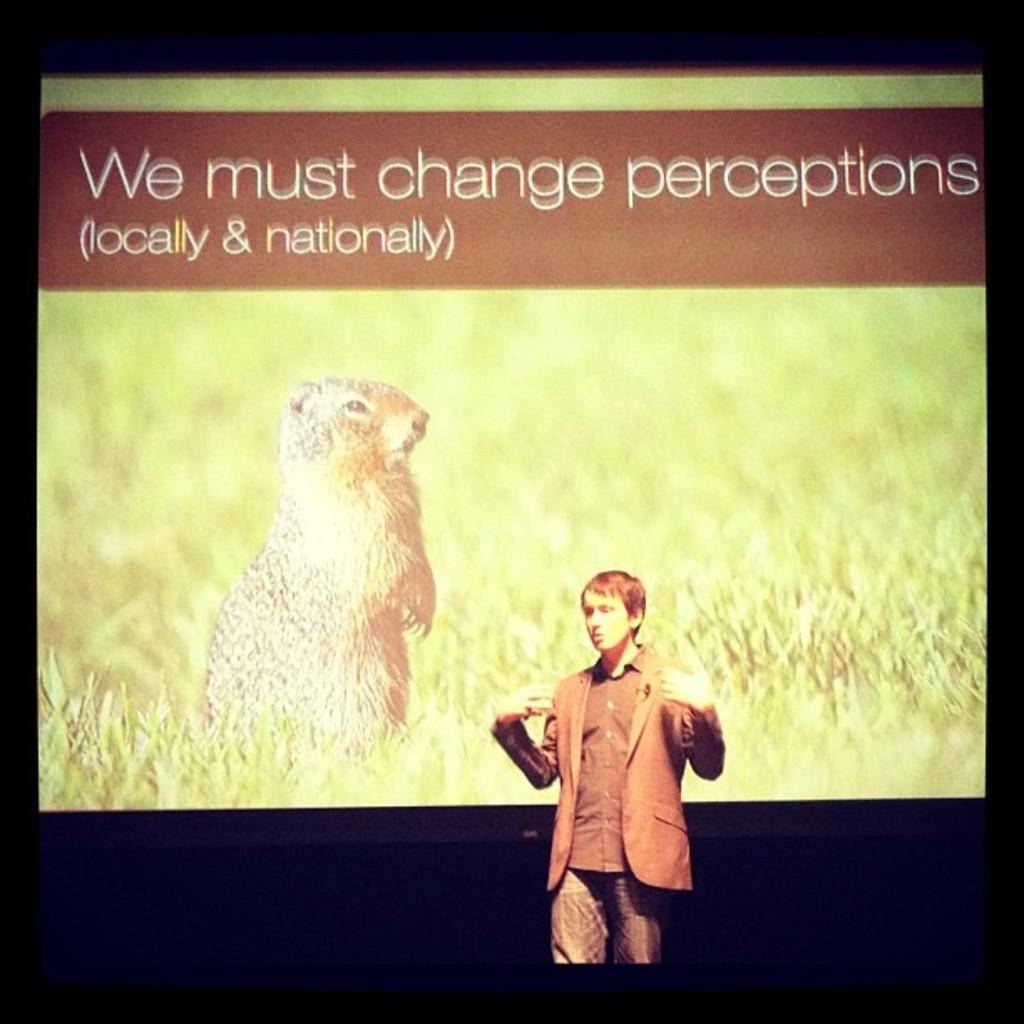What is the main subject of the image? There is a man standing in the image. What is the man wearing? The man is wearing a suit. What can be seen in the background of the image? There is a screen in the background of the image. What type of stem can be seen growing from the man's head in the image? There is no stem growing from the man's head in the image. 